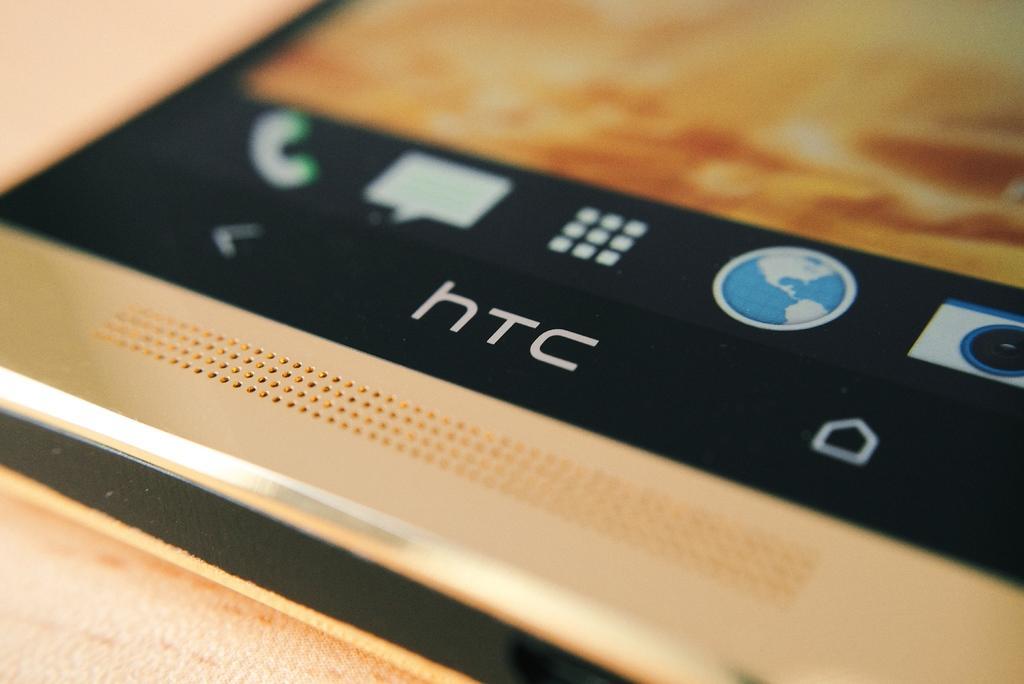How would you summarize this image in a sentence or two? In this image I can see the mobile and I can see some icons in the mobile. It is on the cream color surface. And there is a blurred background. 